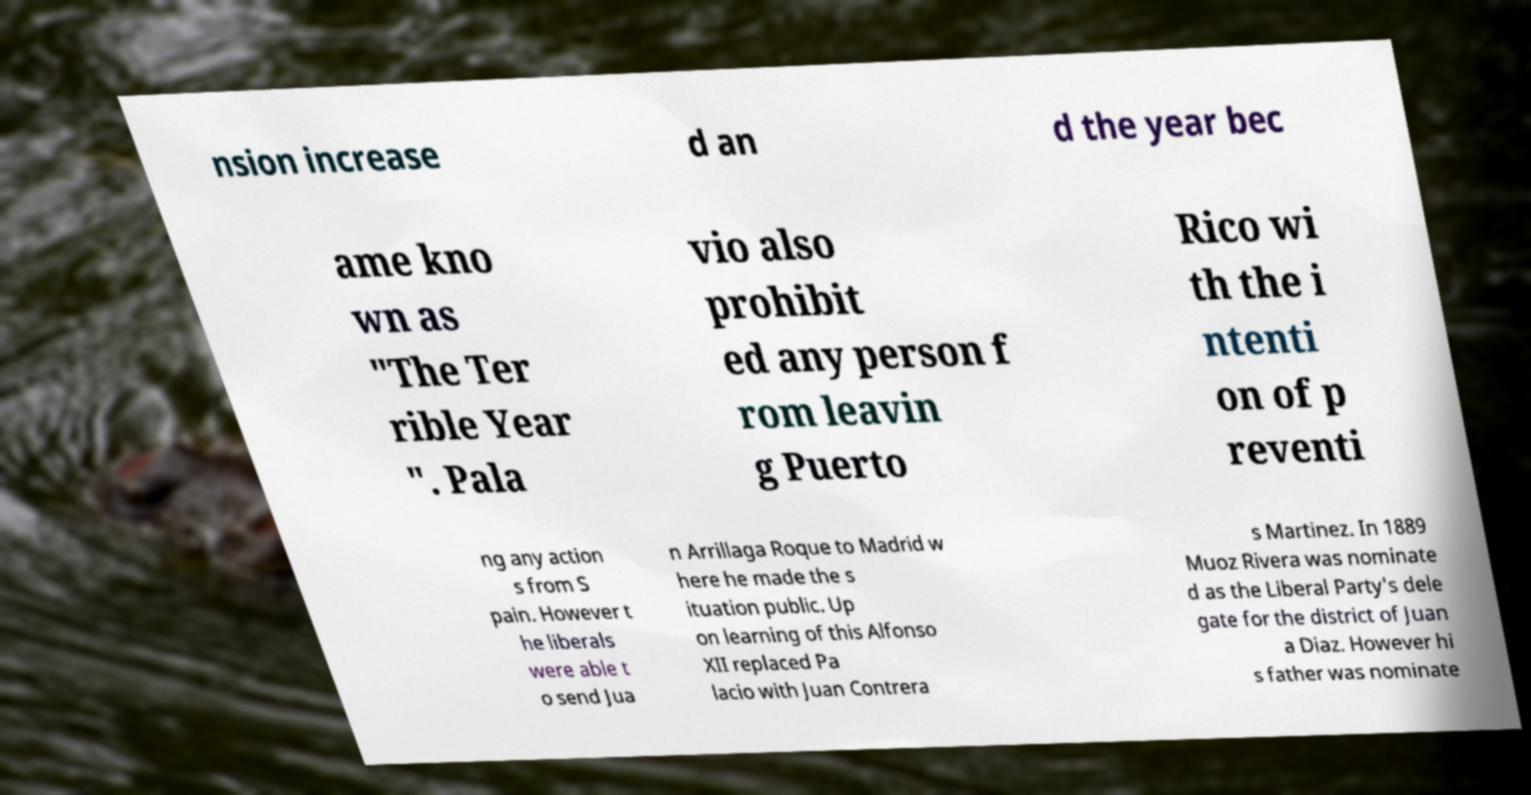Can you accurately transcribe the text from the provided image for me? nsion increase d an d the year bec ame kno wn as "The Ter rible Year ". Pala vio also prohibit ed any person f rom leavin g Puerto Rico wi th the i ntenti on of p reventi ng any action s from S pain. However t he liberals were able t o send Jua n Arrillaga Roque to Madrid w here he made the s ituation public. Up on learning of this Alfonso XII replaced Pa lacio with Juan Contrera s Martinez. In 1889 Muoz Rivera was nominate d as the Liberal Party's dele gate for the district of Juan a Diaz. However hi s father was nominate 